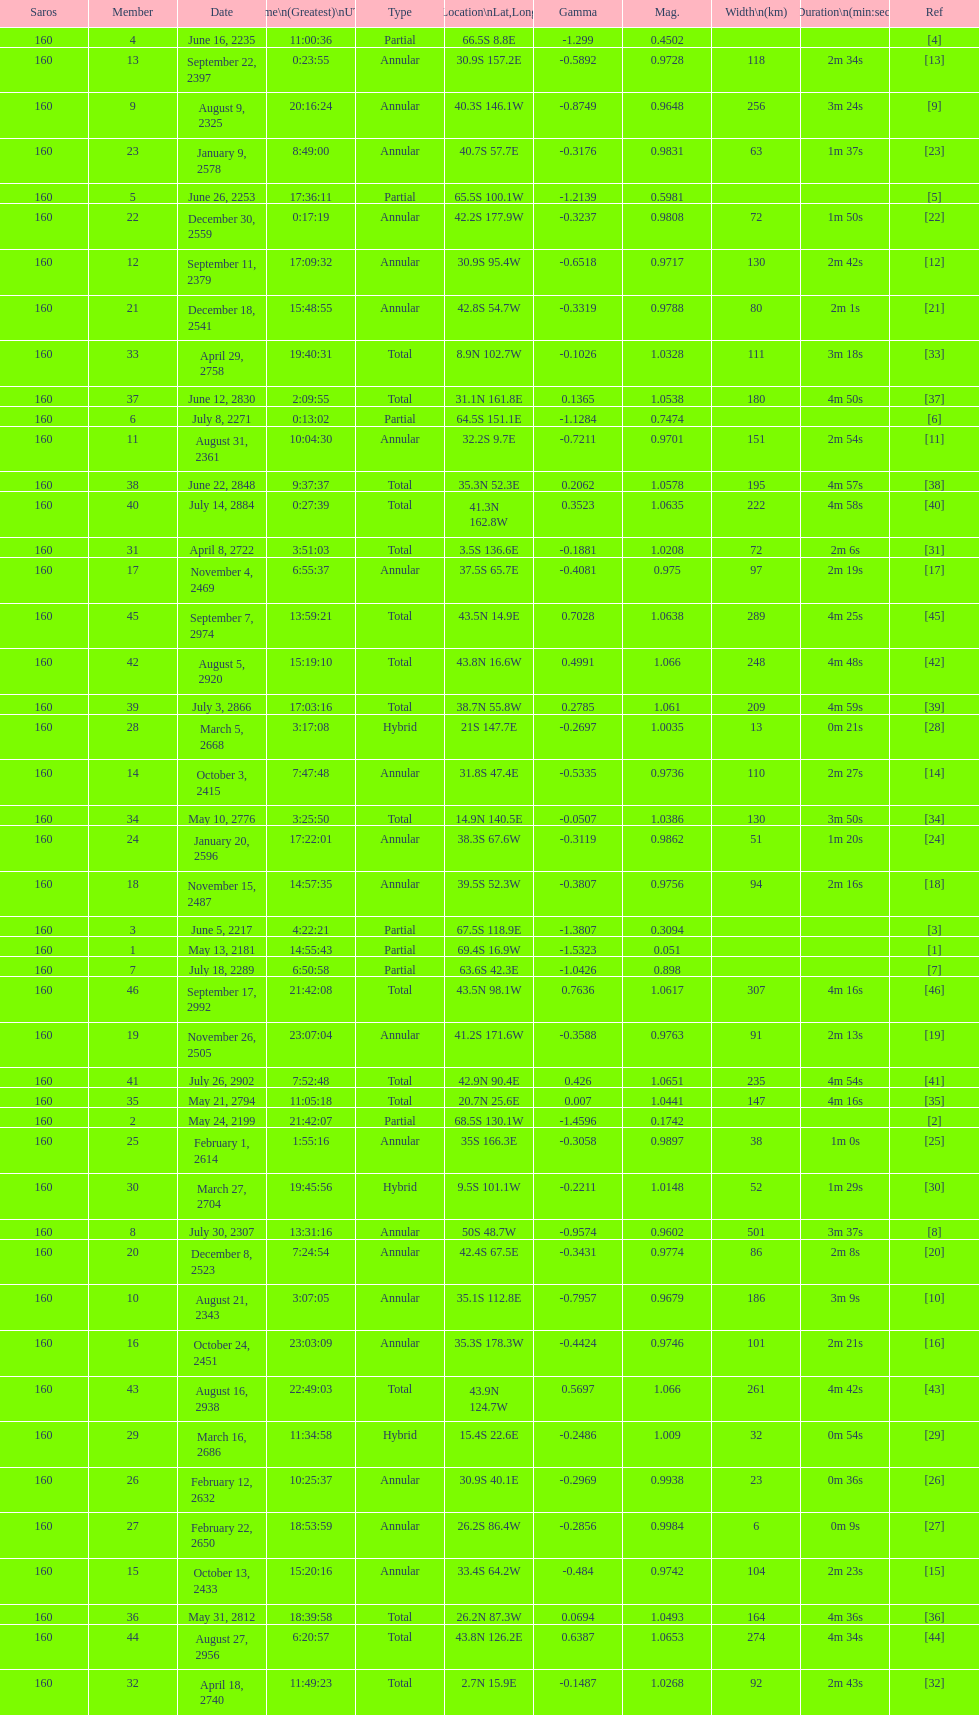What is the previous time for the saros on october 3, 2415? 7:47:48. 